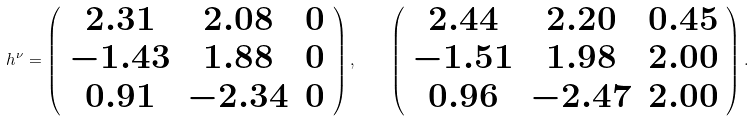<formula> <loc_0><loc_0><loc_500><loc_500>h ^ { \nu } = \left ( \begin{array} { c c c } 2 . 3 1 & 2 . 0 8 & 0 \\ - 1 . 4 3 & 1 . 8 8 & 0 \\ 0 . 9 1 & - 2 . 3 4 & 0 \end{array} \right ) , \quad \left ( \begin{array} { c c c } 2 . 4 4 & 2 . 2 0 & 0 . 4 5 \\ - 1 . 5 1 & 1 . 9 8 & 2 . 0 0 \\ 0 . 9 6 & - 2 . 4 7 & 2 . 0 0 \end{array} \right ) .</formula> 